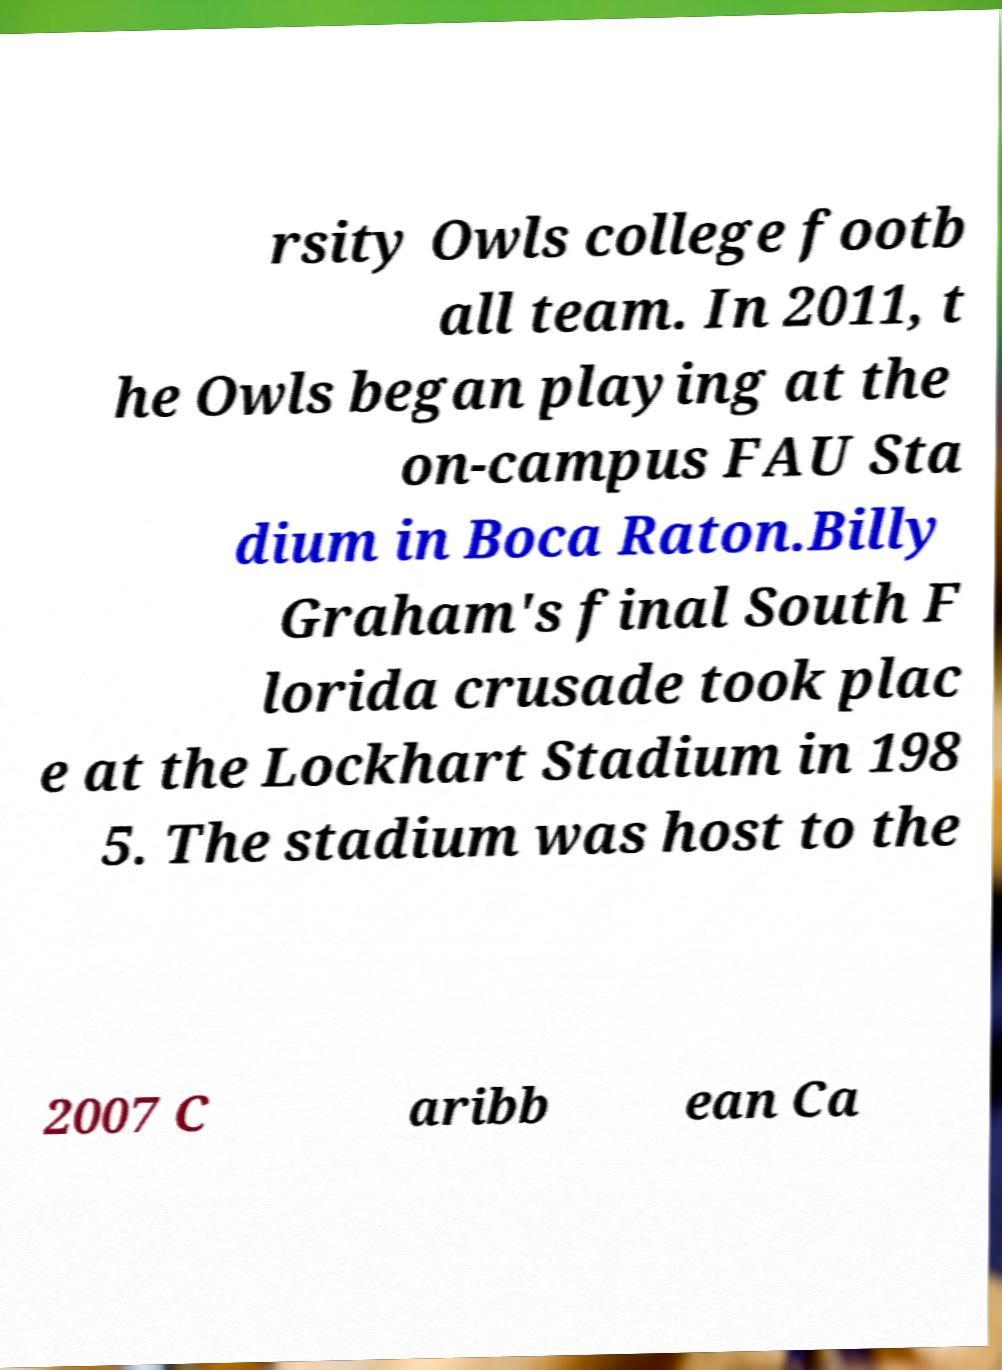Could you extract and type out the text from this image? rsity Owls college footb all team. In 2011, t he Owls began playing at the on-campus FAU Sta dium in Boca Raton.Billy Graham's final South F lorida crusade took plac e at the Lockhart Stadium in 198 5. The stadium was host to the 2007 C aribb ean Ca 